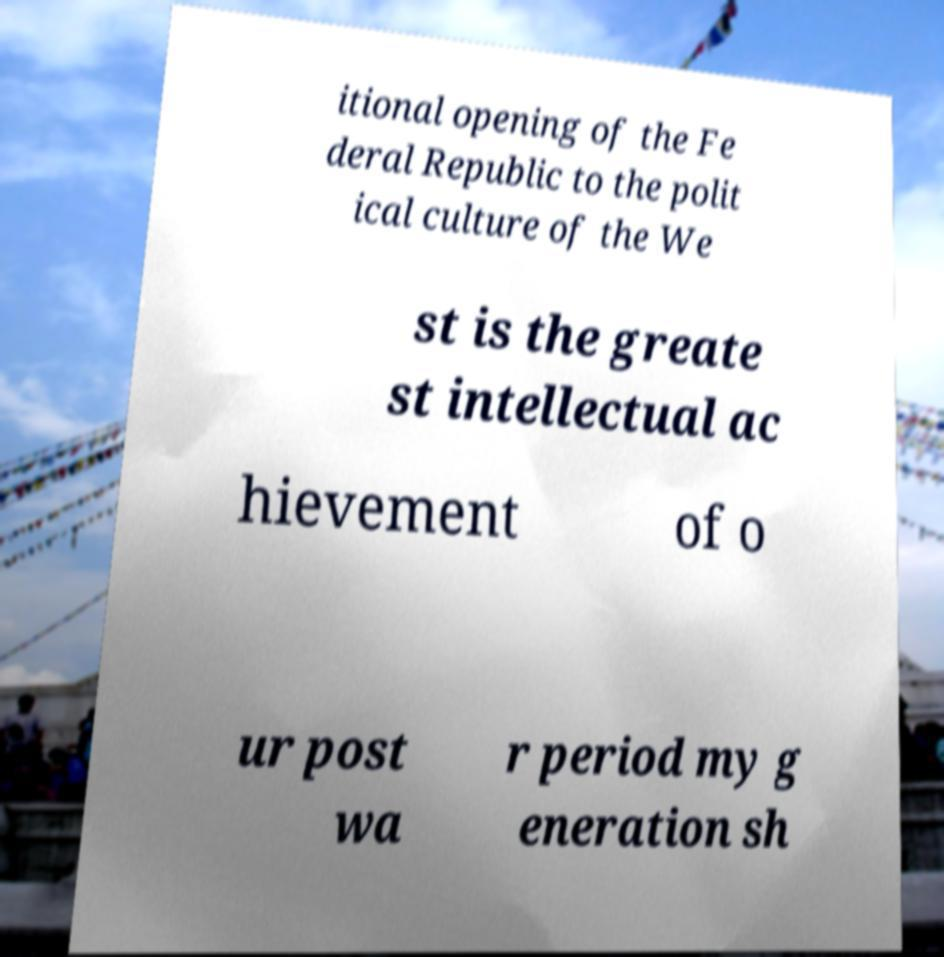For documentation purposes, I need the text within this image transcribed. Could you provide that? itional opening of the Fe deral Republic to the polit ical culture of the We st is the greate st intellectual ac hievement of o ur post wa r period my g eneration sh 